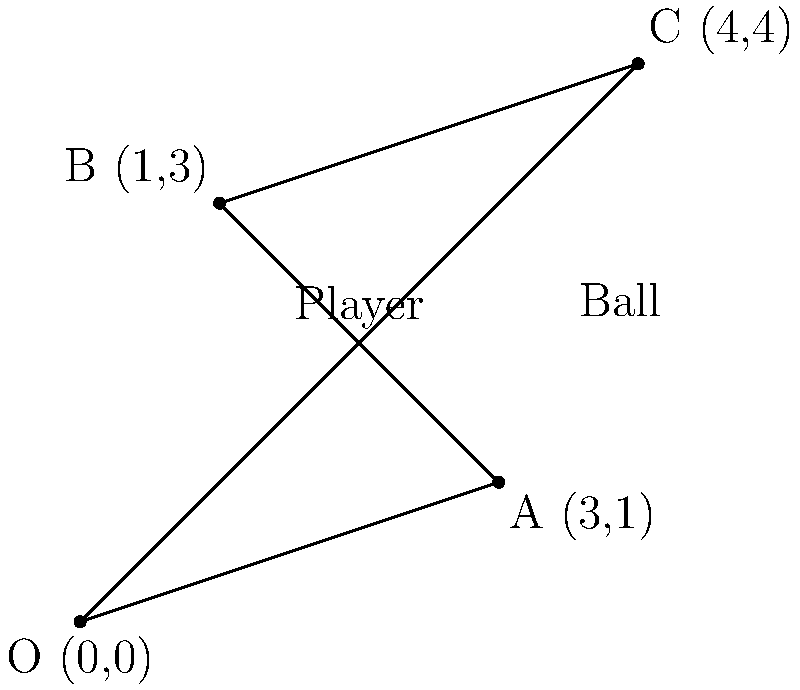As a sports team owner looking to optimize player positioning for better TV coverage, you're analyzing a key play. A player starts at point O (0,0) and needs to intercept a ball that will be at point C (4,4). However, the player must touch bases at points A (3,1) and B (1,3) in that order before reaching the ball. What is the total distance the player must run to reach the ball, assuming they take the shortest path between each point? To solve this problem, we need to calculate the distances between consecutive points and sum them up. We'll use the distance formula between two points: $d = \sqrt{(x_2-x_1)^2 + (y_2-y_1)^2}$

Step 1: Calculate distance from O to A
$d_{OA} = \sqrt{(3-0)^2 + (1-0)^2} = \sqrt{9 + 1} = \sqrt{10}$

Step 2: Calculate distance from A to B
$d_{AB} = \sqrt{(1-3)^2 + (3-1)^2} = \sqrt{4 + 4} = \sqrt{8} = 2\sqrt{2}$

Step 3: Calculate distance from B to C
$d_{BC} = \sqrt{(4-1)^2 + (4-3)^2} = \sqrt{9 + 1} = \sqrt{10}$

Step 4: Sum up all distances
Total distance = $d_{OA} + d_{AB} + d_{BC} = \sqrt{10} + 2\sqrt{2} + \sqrt{10}$

Step 5: Simplify (if needed)
Total distance = $2\sqrt{10} + 2\sqrt{2}$

This result gives us the exact distance in simplest radical form.
Answer: $2\sqrt{10} + 2\sqrt{2}$ 